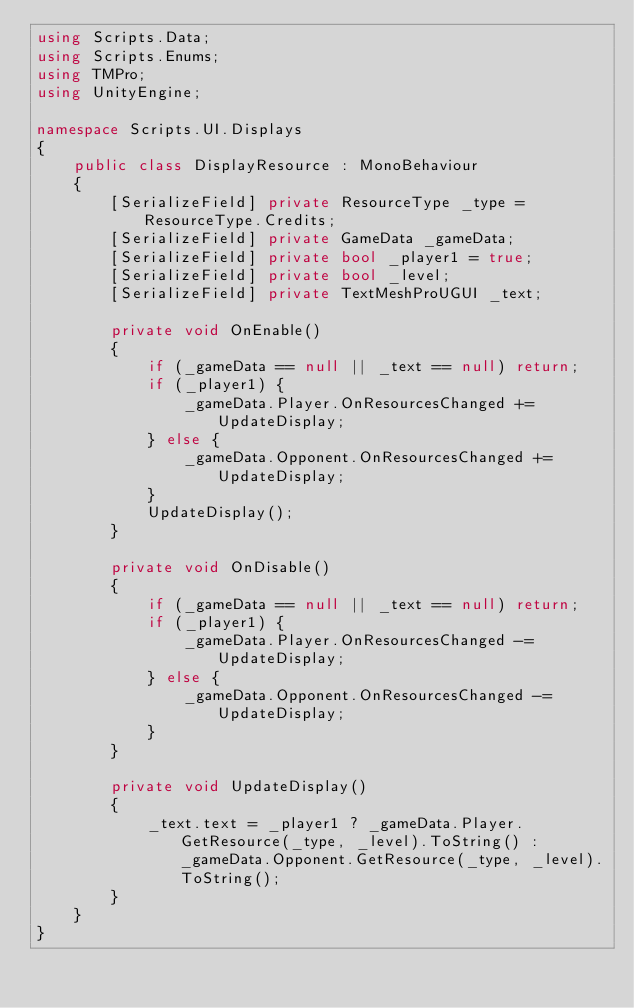Convert code to text. <code><loc_0><loc_0><loc_500><loc_500><_C#_>using Scripts.Data;
using Scripts.Enums;
using TMPro;
using UnityEngine;

namespace Scripts.UI.Displays
{
    public class DisplayResource : MonoBehaviour
    {
        [SerializeField] private ResourceType _type = ResourceType.Credits;
        [SerializeField] private GameData _gameData;
        [SerializeField] private bool _player1 = true;
        [SerializeField] private bool _level;
        [SerializeField] private TextMeshProUGUI _text;

        private void OnEnable()
        {
            if (_gameData == null || _text == null) return;
            if (_player1) {
                _gameData.Player.OnResourcesChanged += UpdateDisplay;
            } else {
                _gameData.Opponent.OnResourcesChanged += UpdateDisplay;
            }
            UpdateDisplay();
        }

        private void OnDisable()
        {
            if (_gameData == null || _text == null) return;
            if (_player1) {
                _gameData.Player.OnResourcesChanged -= UpdateDisplay;
            } else {
                _gameData.Opponent.OnResourcesChanged -= UpdateDisplay;
            }
        }

        private void UpdateDisplay()
        {
            _text.text = _player1 ? _gameData.Player.GetResource(_type, _level).ToString() : _gameData.Opponent.GetResource(_type, _level).ToString();
        }
    }
}</code> 